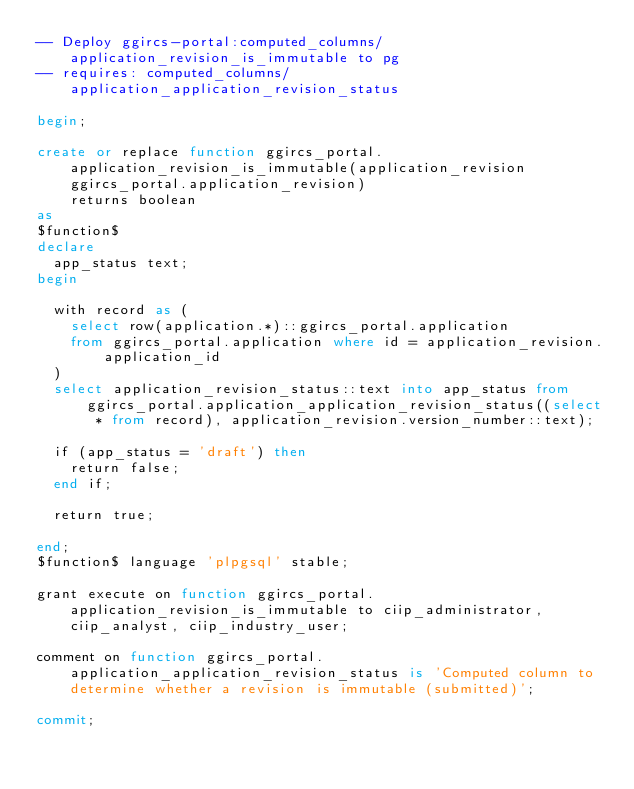<code> <loc_0><loc_0><loc_500><loc_500><_SQL_>-- Deploy ggircs-portal:computed_columns/application_revision_is_immutable to pg
-- requires: computed_columns/application_application_revision_status

begin;

create or replace function ggircs_portal.application_revision_is_immutable(application_revision ggircs_portal.application_revision)
    returns boolean
as
$function$
declare
  app_status text;
begin

  with record as (
    select row(application.*)::ggircs_portal.application
    from ggircs_portal.application where id = application_revision.application_id
  )
  select application_revision_status::text into app_status from ggircs_portal.application_application_revision_status((select * from record), application_revision.version_number::text);

  if (app_status = 'draft') then
    return false;
  end if;

  return true;

end;
$function$ language 'plpgsql' stable;

grant execute on function ggircs_portal.application_revision_is_immutable to ciip_administrator, ciip_analyst, ciip_industry_user;

comment on function ggircs_portal.application_application_revision_status is 'Computed column to determine whether a revision is immutable (submitted)';

commit;
</code> 